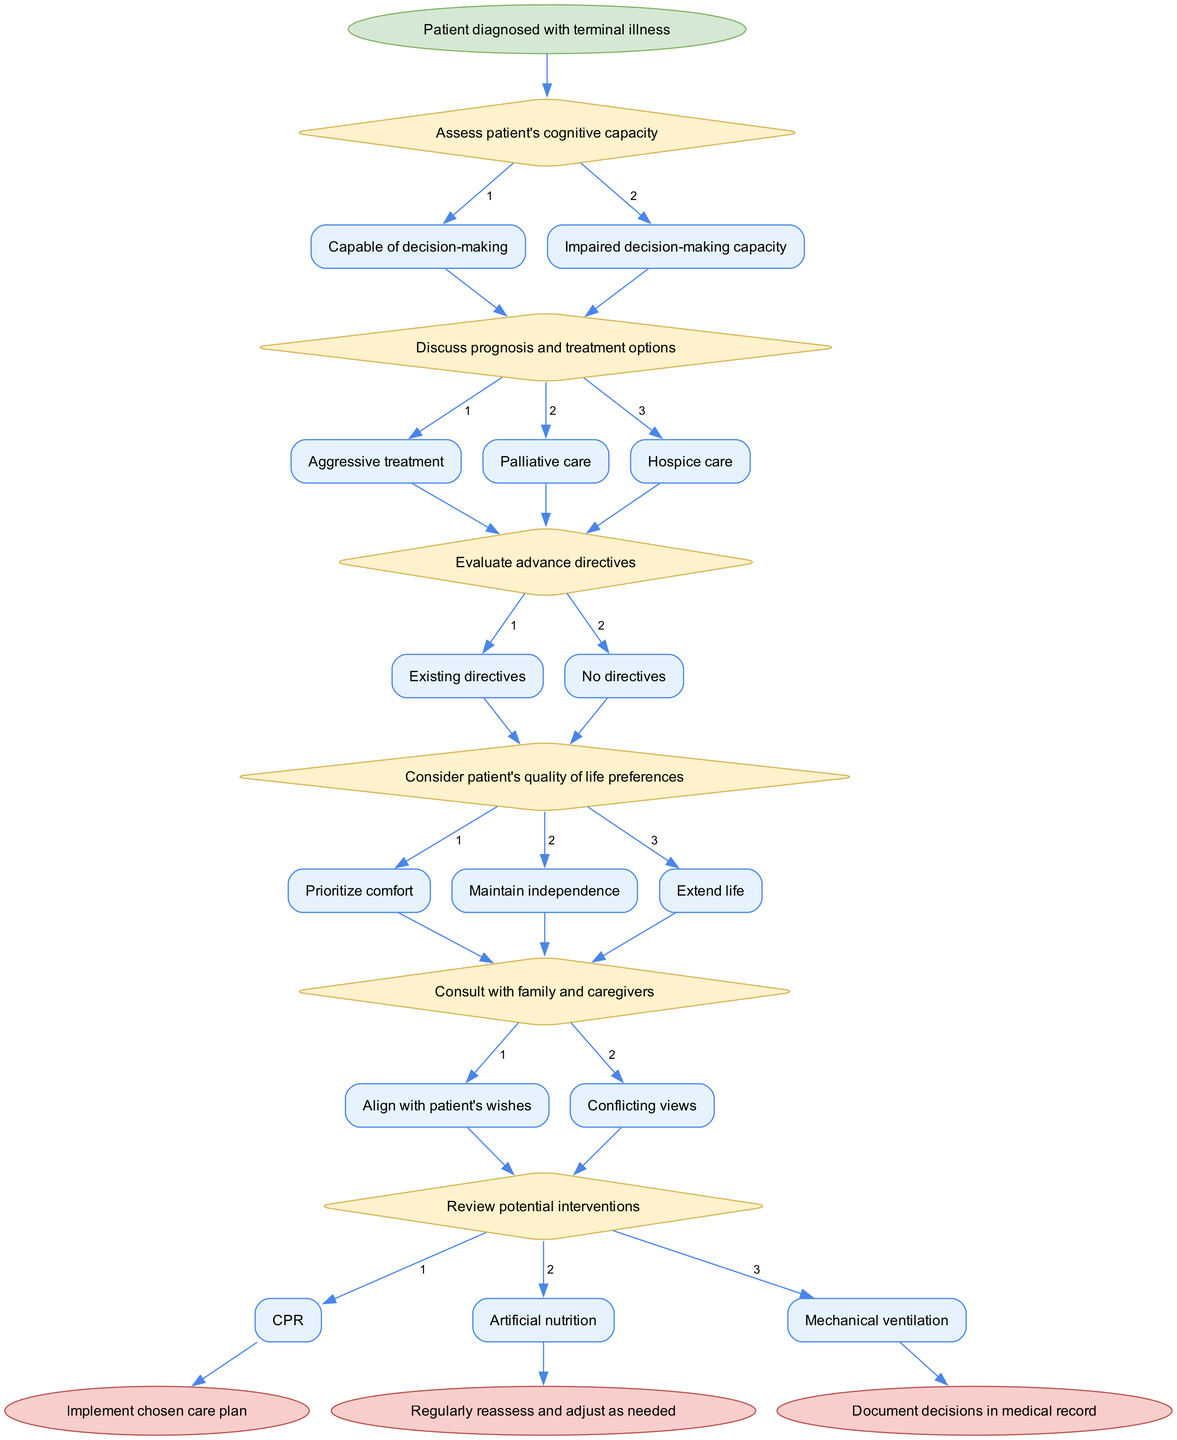What is the start node of the diagram? The start node is indicated at the very top of the flowchart and represents the initial situation before any decisions are made. In this diagram, it is labeled as "Patient diagnosed with terminal illness."
Answer: Patient diagnosed with terminal illness How many decision nodes are present in the diagram? The decision nodes are the diamonds in the diagram where choices are made. By counting these nodes, we find there are six decision nodes in total.
Answer: 6 What is the first decision made after assessing cognitive capacity? Following the assessment of the patient's cognitive capacity, the next decision involves discussing prognosis and treatment options, a critical step in understanding the patient's care.
Answer: Discuss prognosis and treatment options What are the edges stemming from the node 'Consider patient's quality of life preferences'? This node represents various options regarding the patient's values in care. The edges leading from this node include "Prioritize comfort," "Maintain independence," and "Extend life."
Answer: Prioritize comfort, Maintain independence, Extend life What happens if the patient has impaired decision-making capacity? If the patient's capacity is impaired, the flow would logically require reevaluating responsibility for decision-making, typically involving family consultation or alternative means of determining care wishes, though the specific pathway is not given in the initial description.
Answer: Consult with family and caregivers Which care plan is implemented after reviewing potential interventions? The diagram concludes with a process of implementing the chosen care plan after reviewing potential interventions such as CPR, artificial nutrition, or mechanical ventilation. This step solidifies the decisions made prior.
Answer: Implement chosen care plan How are decisions documented in the flowchart? The flowchart specifies that after implementing a care plan, it is crucial to document all decisions in the medical record to ensure continuity of care and clear communication among healthcare providers.
Answer: Document decisions in medical record What are the potential treatments discussed after assessing cognitive capacity? After assessing cognitive capacity, the discussion focuses on several treatment options available for the patient, particularly "Aggressive treatment," "Palliative care," and "Hospice care," each representing different approaches to care.
Answer: Aggressive treatment, Palliative care, Hospice care 